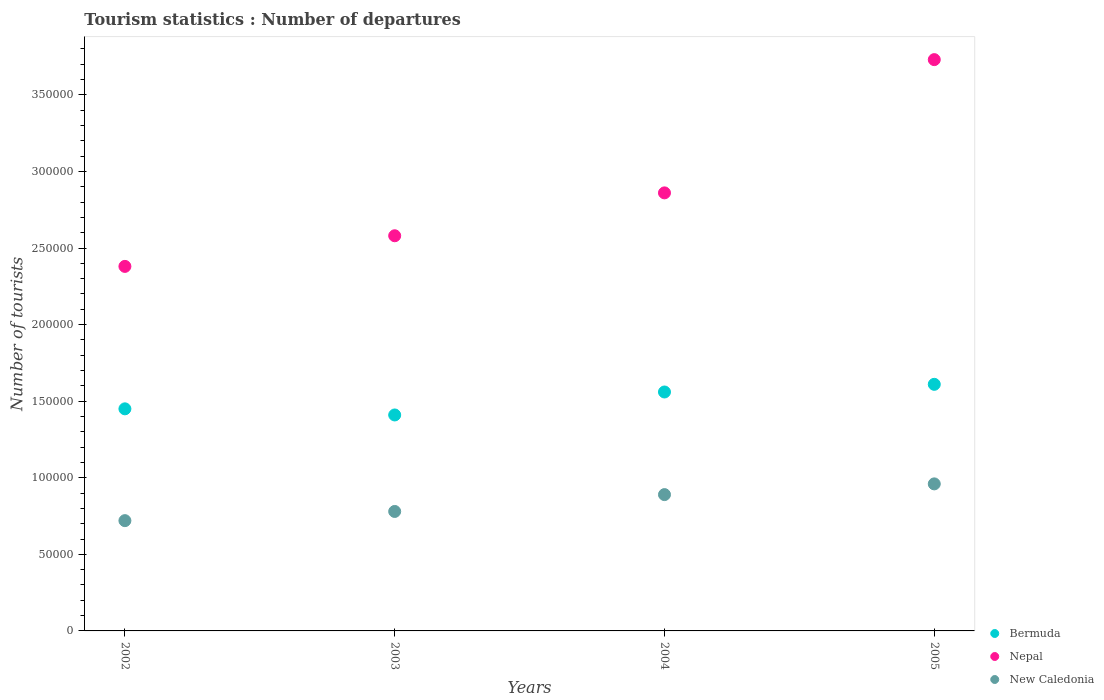How many different coloured dotlines are there?
Provide a succinct answer. 3. What is the number of tourist departures in Bermuda in 2005?
Your response must be concise. 1.61e+05. Across all years, what is the maximum number of tourist departures in Bermuda?
Offer a very short reply. 1.61e+05. Across all years, what is the minimum number of tourist departures in Nepal?
Make the answer very short. 2.38e+05. In which year was the number of tourist departures in New Caledonia minimum?
Provide a short and direct response. 2002. What is the total number of tourist departures in New Caledonia in the graph?
Your response must be concise. 3.35e+05. What is the difference between the number of tourist departures in New Caledonia in 2003 and that in 2005?
Offer a terse response. -1.80e+04. What is the difference between the number of tourist departures in Nepal in 2004 and the number of tourist departures in Bermuda in 2003?
Your answer should be compact. 1.45e+05. What is the average number of tourist departures in New Caledonia per year?
Give a very brief answer. 8.38e+04. In the year 2002, what is the difference between the number of tourist departures in Nepal and number of tourist departures in New Caledonia?
Give a very brief answer. 1.66e+05. What is the ratio of the number of tourist departures in Bermuda in 2003 to that in 2005?
Provide a succinct answer. 0.88. Is the difference between the number of tourist departures in Nepal in 2003 and 2004 greater than the difference between the number of tourist departures in New Caledonia in 2003 and 2004?
Your answer should be compact. No. What is the difference between the highest and the lowest number of tourist departures in Bermuda?
Offer a terse response. 2.00e+04. In how many years, is the number of tourist departures in Nepal greater than the average number of tourist departures in Nepal taken over all years?
Your answer should be very brief. 1. Is it the case that in every year, the sum of the number of tourist departures in Nepal and number of tourist departures in New Caledonia  is greater than the number of tourist departures in Bermuda?
Ensure brevity in your answer.  Yes. Does the number of tourist departures in New Caledonia monotonically increase over the years?
Make the answer very short. Yes. Is the number of tourist departures in Bermuda strictly less than the number of tourist departures in New Caledonia over the years?
Provide a succinct answer. No. Are the values on the major ticks of Y-axis written in scientific E-notation?
Provide a succinct answer. No. Does the graph contain any zero values?
Provide a succinct answer. No. Does the graph contain grids?
Make the answer very short. No. Where does the legend appear in the graph?
Provide a succinct answer. Bottom right. What is the title of the graph?
Your answer should be very brief. Tourism statistics : Number of departures. Does "Benin" appear as one of the legend labels in the graph?
Keep it short and to the point. No. What is the label or title of the X-axis?
Make the answer very short. Years. What is the label or title of the Y-axis?
Offer a very short reply. Number of tourists. What is the Number of tourists in Bermuda in 2002?
Keep it short and to the point. 1.45e+05. What is the Number of tourists of Nepal in 2002?
Provide a short and direct response. 2.38e+05. What is the Number of tourists in New Caledonia in 2002?
Give a very brief answer. 7.20e+04. What is the Number of tourists of Bermuda in 2003?
Keep it short and to the point. 1.41e+05. What is the Number of tourists in Nepal in 2003?
Make the answer very short. 2.58e+05. What is the Number of tourists of New Caledonia in 2003?
Keep it short and to the point. 7.80e+04. What is the Number of tourists of Bermuda in 2004?
Ensure brevity in your answer.  1.56e+05. What is the Number of tourists in Nepal in 2004?
Make the answer very short. 2.86e+05. What is the Number of tourists in New Caledonia in 2004?
Keep it short and to the point. 8.90e+04. What is the Number of tourists of Bermuda in 2005?
Ensure brevity in your answer.  1.61e+05. What is the Number of tourists of Nepal in 2005?
Keep it short and to the point. 3.73e+05. What is the Number of tourists in New Caledonia in 2005?
Make the answer very short. 9.60e+04. Across all years, what is the maximum Number of tourists of Bermuda?
Keep it short and to the point. 1.61e+05. Across all years, what is the maximum Number of tourists of Nepal?
Your response must be concise. 3.73e+05. Across all years, what is the maximum Number of tourists of New Caledonia?
Keep it short and to the point. 9.60e+04. Across all years, what is the minimum Number of tourists of Bermuda?
Provide a short and direct response. 1.41e+05. Across all years, what is the minimum Number of tourists of Nepal?
Give a very brief answer. 2.38e+05. Across all years, what is the minimum Number of tourists of New Caledonia?
Give a very brief answer. 7.20e+04. What is the total Number of tourists of Bermuda in the graph?
Keep it short and to the point. 6.03e+05. What is the total Number of tourists in Nepal in the graph?
Make the answer very short. 1.16e+06. What is the total Number of tourists in New Caledonia in the graph?
Provide a short and direct response. 3.35e+05. What is the difference between the Number of tourists in Bermuda in 2002 and that in 2003?
Ensure brevity in your answer.  4000. What is the difference between the Number of tourists of Nepal in 2002 and that in 2003?
Your response must be concise. -2.00e+04. What is the difference between the Number of tourists in New Caledonia in 2002 and that in 2003?
Make the answer very short. -6000. What is the difference between the Number of tourists of Bermuda in 2002 and that in 2004?
Provide a short and direct response. -1.10e+04. What is the difference between the Number of tourists of Nepal in 2002 and that in 2004?
Give a very brief answer. -4.80e+04. What is the difference between the Number of tourists in New Caledonia in 2002 and that in 2004?
Provide a short and direct response. -1.70e+04. What is the difference between the Number of tourists in Bermuda in 2002 and that in 2005?
Your answer should be compact. -1.60e+04. What is the difference between the Number of tourists of Nepal in 2002 and that in 2005?
Give a very brief answer. -1.35e+05. What is the difference between the Number of tourists of New Caledonia in 2002 and that in 2005?
Keep it short and to the point. -2.40e+04. What is the difference between the Number of tourists of Bermuda in 2003 and that in 2004?
Make the answer very short. -1.50e+04. What is the difference between the Number of tourists in Nepal in 2003 and that in 2004?
Offer a terse response. -2.80e+04. What is the difference between the Number of tourists in New Caledonia in 2003 and that in 2004?
Provide a short and direct response. -1.10e+04. What is the difference between the Number of tourists of Bermuda in 2003 and that in 2005?
Give a very brief answer. -2.00e+04. What is the difference between the Number of tourists of Nepal in 2003 and that in 2005?
Give a very brief answer. -1.15e+05. What is the difference between the Number of tourists in New Caledonia in 2003 and that in 2005?
Your answer should be very brief. -1.80e+04. What is the difference between the Number of tourists of Bermuda in 2004 and that in 2005?
Your response must be concise. -5000. What is the difference between the Number of tourists in Nepal in 2004 and that in 2005?
Your response must be concise. -8.70e+04. What is the difference between the Number of tourists of New Caledonia in 2004 and that in 2005?
Make the answer very short. -7000. What is the difference between the Number of tourists in Bermuda in 2002 and the Number of tourists in Nepal in 2003?
Your response must be concise. -1.13e+05. What is the difference between the Number of tourists of Bermuda in 2002 and the Number of tourists of New Caledonia in 2003?
Your answer should be very brief. 6.70e+04. What is the difference between the Number of tourists of Bermuda in 2002 and the Number of tourists of Nepal in 2004?
Keep it short and to the point. -1.41e+05. What is the difference between the Number of tourists of Bermuda in 2002 and the Number of tourists of New Caledonia in 2004?
Keep it short and to the point. 5.60e+04. What is the difference between the Number of tourists in Nepal in 2002 and the Number of tourists in New Caledonia in 2004?
Give a very brief answer. 1.49e+05. What is the difference between the Number of tourists in Bermuda in 2002 and the Number of tourists in Nepal in 2005?
Offer a terse response. -2.28e+05. What is the difference between the Number of tourists of Bermuda in 2002 and the Number of tourists of New Caledonia in 2005?
Your answer should be very brief. 4.90e+04. What is the difference between the Number of tourists of Nepal in 2002 and the Number of tourists of New Caledonia in 2005?
Give a very brief answer. 1.42e+05. What is the difference between the Number of tourists of Bermuda in 2003 and the Number of tourists of Nepal in 2004?
Make the answer very short. -1.45e+05. What is the difference between the Number of tourists in Bermuda in 2003 and the Number of tourists in New Caledonia in 2004?
Give a very brief answer. 5.20e+04. What is the difference between the Number of tourists in Nepal in 2003 and the Number of tourists in New Caledonia in 2004?
Provide a short and direct response. 1.69e+05. What is the difference between the Number of tourists of Bermuda in 2003 and the Number of tourists of Nepal in 2005?
Your answer should be very brief. -2.32e+05. What is the difference between the Number of tourists in Bermuda in 2003 and the Number of tourists in New Caledonia in 2005?
Offer a terse response. 4.50e+04. What is the difference between the Number of tourists in Nepal in 2003 and the Number of tourists in New Caledonia in 2005?
Ensure brevity in your answer.  1.62e+05. What is the difference between the Number of tourists in Bermuda in 2004 and the Number of tourists in Nepal in 2005?
Your answer should be very brief. -2.17e+05. What is the difference between the Number of tourists in Bermuda in 2004 and the Number of tourists in New Caledonia in 2005?
Provide a short and direct response. 6.00e+04. What is the difference between the Number of tourists of Nepal in 2004 and the Number of tourists of New Caledonia in 2005?
Ensure brevity in your answer.  1.90e+05. What is the average Number of tourists in Bermuda per year?
Your response must be concise. 1.51e+05. What is the average Number of tourists in Nepal per year?
Your answer should be very brief. 2.89e+05. What is the average Number of tourists in New Caledonia per year?
Provide a succinct answer. 8.38e+04. In the year 2002, what is the difference between the Number of tourists of Bermuda and Number of tourists of Nepal?
Offer a very short reply. -9.30e+04. In the year 2002, what is the difference between the Number of tourists in Bermuda and Number of tourists in New Caledonia?
Give a very brief answer. 7.30e+04. In the year 2002, what is the difference between the Number of tourists in Nepal and Number of tourists in New Caledonia?
Your answer should be very brief. 1.66e+05. In the year 2003, what is the difference between the Number of tourists of Bermuda and Number of tourists of Nepal?
Provide a short and direct response. -1.17e+05. In the year 2003, what is the difference between the Number of tourists in Bermuda and Number of tourists in New Caledonia?
Offer a very short reply. 6.30e+04. In the year 2003, what is the difference between the Number of tourists of Nepal and Number of tourists of New Caledonia?
Provide a short and direct response. 1.80e+05. In the year 2004, what is the difference between the Number of tourists of Bermuda and Number of tourists of Nepal?
Your answer should be very brief. -1.30e+05. In the year 2004, what is the difference between the Number of tourists of Bermuda and Number of tourists of New Caledonia?
Give a very brief answer. 6.70e+04. In the year 2004, what is the difference between the Number of tourists of Nepal and Number of tourists of New Caledonia?
Your answer should be very brief. 1.97e+05. In the year 2005, what is the difference between the Number of tourists in Bermuda and Number of tourists in Nepal?
Provide a succinct answer. -2.12e+05. In the year 2005, what is the difference between the Number of tourists in Bermuda and Number of tourists in New Caledonia?
Offer a terse response. 6.50e+04. In the year 2005, what is the difference between the Number of tourists in Nepal and Number of tourists in New Caledonia?
Your response must be concise. 2.77e+05. What is the ratio of the Number of tourists of Bermuda in 2002 to that in 2003?
Provide a short and direct response. 1.03. What is the ratio of the Number of tourists in Nepal in 2002 to that in 2003?
Provide a short and direct response. 0.92. What is the ratio of the Number of tourists in New Caledonia in 2002 to that in 2003?
Your response must be concise. 0.92. What is the ratio of the Number of tourists in Bermuda in 2002 to that in 2004?
Your response must be concise. 0.93. What is the ratio of the Number of tourists in Nepal in 2002 to that in 2004?
Offer a terse response. 0.83. What is the ratio of the Number of tourists of New Caledonia in 2002 to that in 2004?
Your answer should be compact. 0.81. What is the ratio of the Number of tourists in Bermuda in 2002 to that in 2005?
Keep it short and to the point. 0.9. What is the ratio of the Number of tourists in Nepal in 2002 to that in 2005?
Ensure brevity in your answer.  0.64. What is the ratio of the Number of tourists in New Caledonia in 2002 to that in 2005?
Offer a terse response. 0.75. What is the ratio of the Number of tourists in Bermuda in 2003 to that in 2004?
Provide a short and direct response. 0.9. What is the ratio of the Number of tourists of Nepal in 2003 to that in 2004?
Give a very brief answer. 0.9. What is the ratio of the Number of tourists in New Caledonia in 2003 to that in 2004?
Provide a short and direct response. 0.88. What is the ratio of the Number of tourists in Bermuda in 2003 to that in 2005?
Offer a very short reply. 0.88. What is the ratio of the Number of tourists in Nepal in 2003 to that in 2005?
Make the answer very short. 0.69. What is the ratio of the Number of tourists in New Caledonia in 2003 to that in 2005?
Provide a succinct answer. 0.81. What is the ratio of the Number of tourists in Bermuda in 2004 to that in 2005?
Keep it short and to the point. 0.97. What is the ratio of the Number of tourists in Nepal in 2004 to that in 2005?
Your answer should be compact. 0.77. What is the ratio of the Number of tourists in New Caledonia in 2004 to that in 2005?
Provide a succinct answer. 0.93. What is the difference between the highest and the second highest Number of tourists of Nepal?
Provide a short and direct response. 8.70e+04. What is the difference between the highest and the second highest Number of tourists in New Caledonia?
Offer a very short reply. 7000. What is the difference between the highest and the lowest Number of tourists of Nepal?
Keep it short and to the point. 1.35e+05. What is the difference between the highest and the lowest Number of tourists of New Caledonia?
Provide a succinct answer. 2.40e+04. 